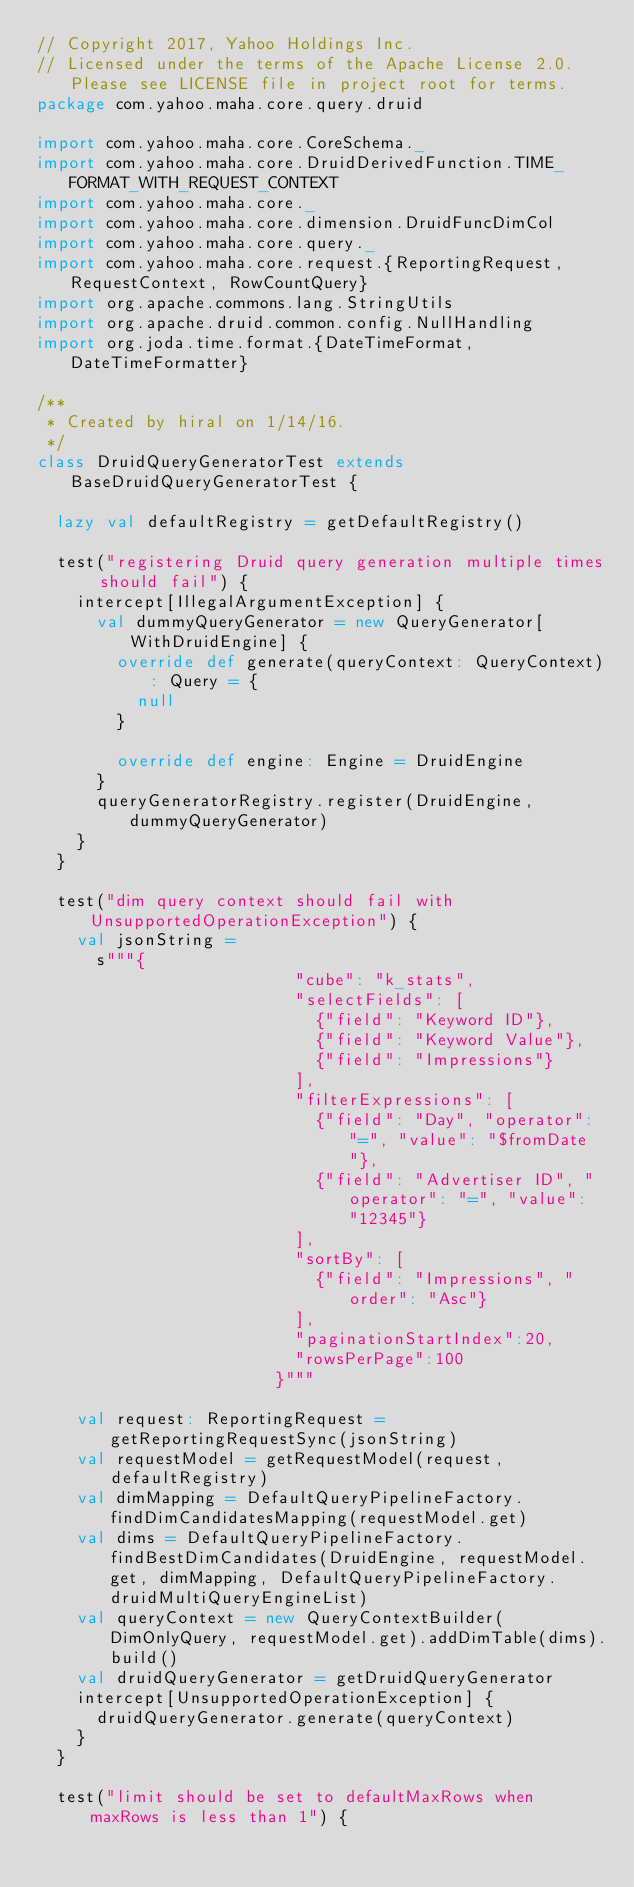Convert code to text. <code><loc_0><loc_0><loc_500><loc_500><_Scala_>// Copyright 2017, Yahoo Holdings Inc.
// Licensed under the terms of the Apache License 2.0. Please see LICENSE file in project root for terms.
package com.yahoo.maha.core.query.druid

import com.yahoo.maha.core.CoreSchema._
import com.yahoo.maha.core.DruidDerivedFunction.TIME_FORMAT_WITH_REQUEST_CONTEXT
import com.yahoo.maha.core._
import com.yahoo.maha.core.dimension.DruidFuncDimCol
import com.yahoo.maha.core.query._
import com.yahoo.maha.core.request.{ReportingRequest, RequestContext, RowCountQuery}
import org.apache.commons.lang.StringUtils
import org.apache.druid.common.config.NullHandling
import org.joda.time.format.{DateTimeFormat, DateTimeFormatter}

/**
 * Created by hiral on 1/14/16.
 */
class DruidQueryGeneratorTest extends BaseDruidQueryGeneratorTest {

  lazy val defaultRegistry = getDefaultRegistry()

  test("registering Druid query generation multiple times should fail") {
    intercept[IllegalArgumentException] {
      val dummyQueryGenerator = new QueryGenerator[WithDruidEngine] {
        override def generate(queryContext: QueryContext): Query = {
          null
        }

        override def engine: Engine = DruidEngine
      }
      queryGeneratorRegistry.register(DruidEngine, dummyQueryGenerator)
    }
  }

  test("dim query context should fail with UnsupportedOperationException") {
    val jsonString =
      s"""{
                          "cube": "k_stats",
                          "selectFields": [
                            {"field": "Keyword ID"},
                            {"field": "Keyword Value"},
                            {"field": "Impressions"}
                          ],
                          "filterExpressions": [
                            {"field": "Day", "operator": "=", "value": "$fromDate"},
                            {"field": "Advertiser ID", "operator": "=", "value": "12345"}
                          ],
                          "sortBy": [
                            {"field": "Impressions", "order": "Asc"}
                          ],
                          "paginationStartIndex":20,
                          "rowsPerPage":100
                        }"""

    val request: ReportingRequest = getReportingRequestSync(jsonString)
    val requestModel = getRequestModel(request, defaultRegistry)
    val dimMapping = DefaultQueryPipelineFactory.findDimCandidatesMapping(requestModel.get)
    val dims = DefaultQueryPipelineFactory.findBestDimCandidates(DruidEngine, requestModel.get, dimMapping, DefaultQueryPipelineFactory.druidMultiQueryEngineList)
    val queryContext = new QueryContextBuilder(DimOnlyQuery, requestModel.get).addDimTable(dims).build()
    val druidQueryGenerator = getDruidQueryGenerator
    intercept[UnsupportedOperationException] {
      druidQueryGenerator.generate(queryContext)
    }
  }

  test("limit should be set to defaultMaxRows when maxRows is less than 1") {</code> 